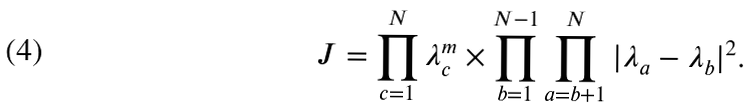<formula> <loc_0><loc_0><loc_500><loc_500>J = \prod _ { c = 1 } ^ { N } \lambda _ { c } ^ { m } \times \prod _ { b = 1 } ^ { N - 1 } \prod _ { a = b + 1 } ^ { N } | \lambda _ { a } - \lambda _ { b } | ^ { 2 } .</formula> 